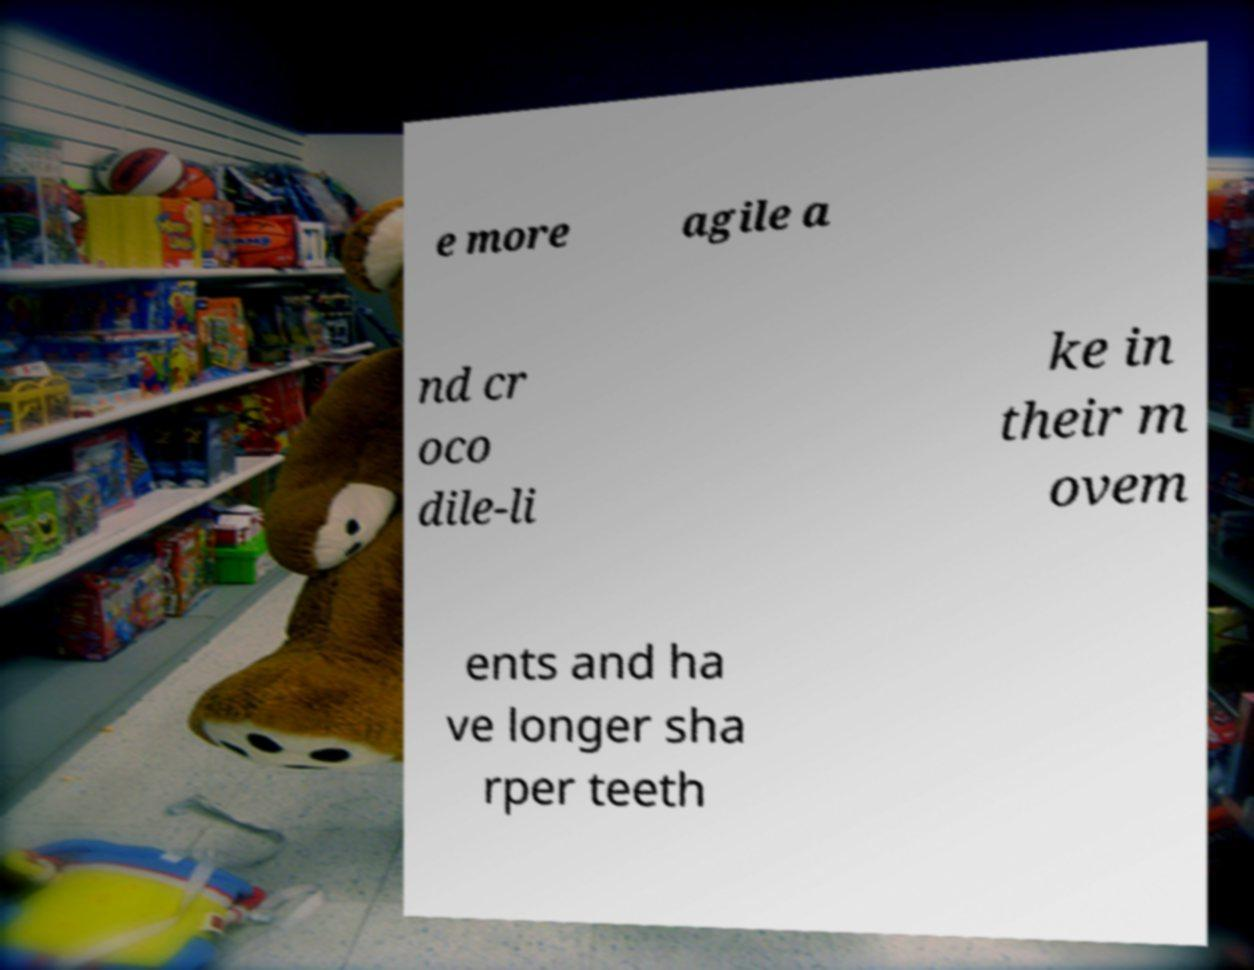For documentation purposes, I need the text within this image transcribed. Could you provide that? e more agile a nd cr oco dile-li ke in their m ovem ents and ha ve longer sha rper teeth 